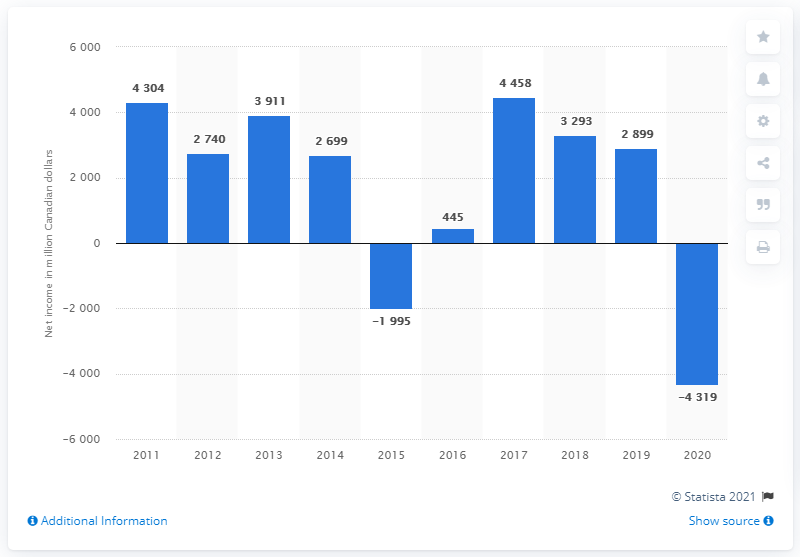Mention a couple of crucial points in this snapshot. In the year 2015, Suncor Energy was unable to generate an annual profit. In 2020, Suncor Energy reported a net loss of CAD 4,304 million. 